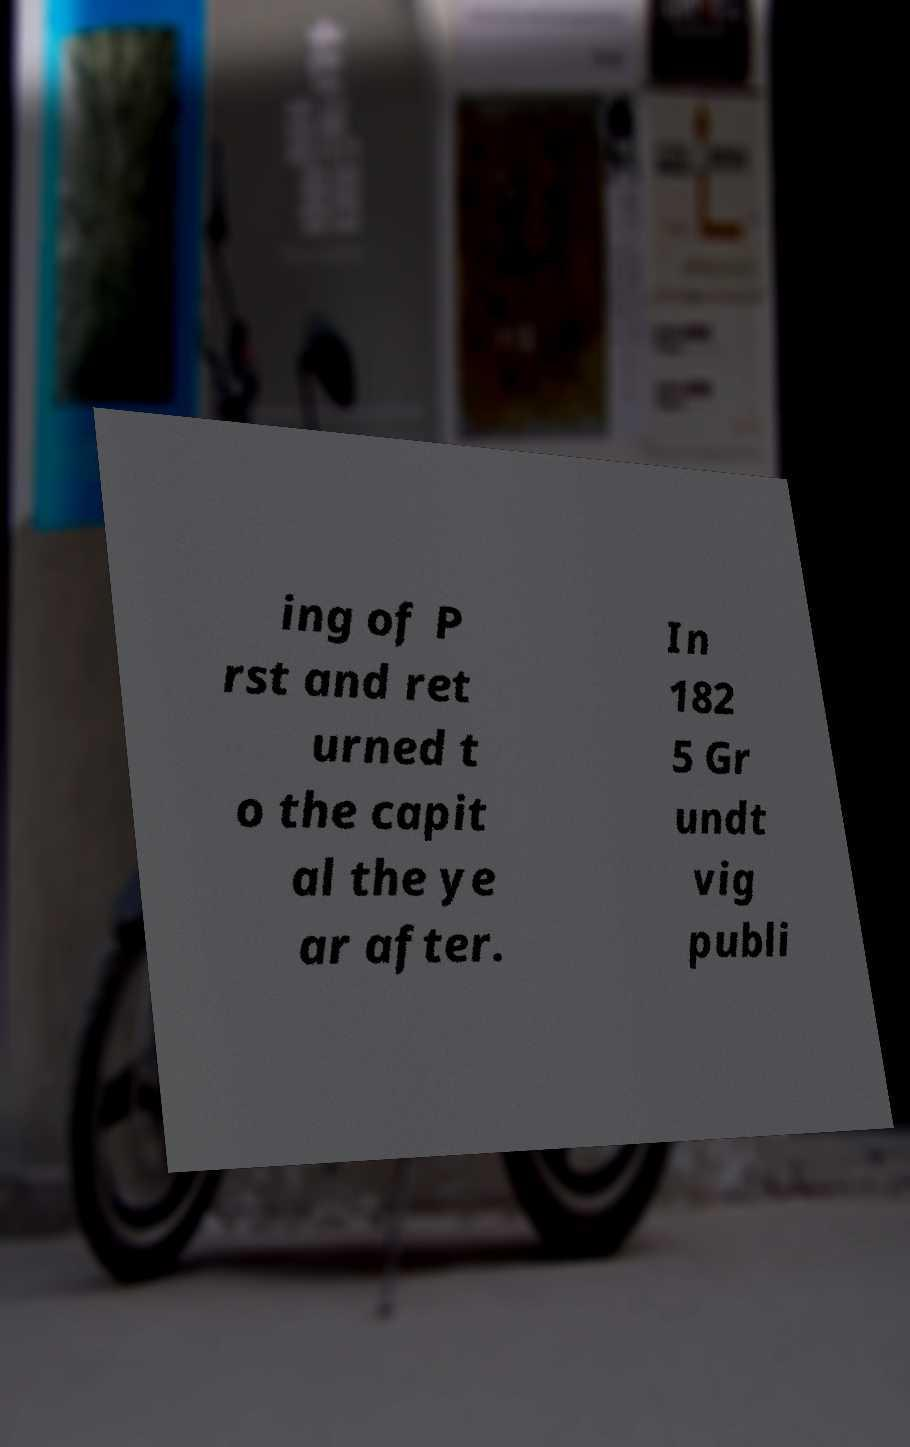Could you assist in decoding the text presented in this image and type it out clearly? ing of P rst and ret urned t o the capit al the ye ar after. In 182 5 Gr undt vig publi 